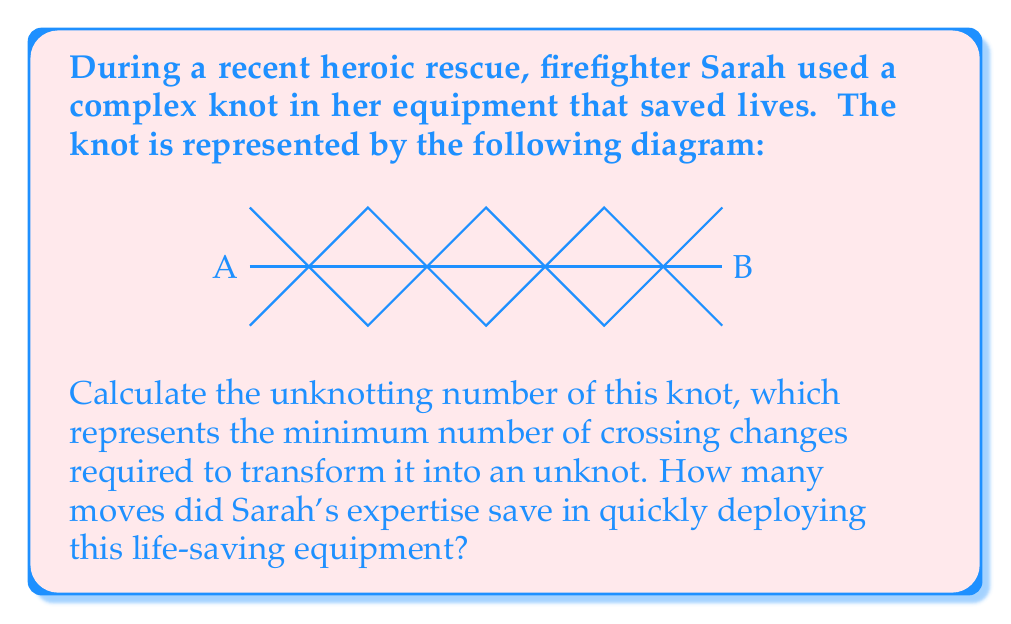Show me your answer to this math problem. To determine the unknotting number of this complex knot, we need to analyze its structure and apply principles from knot theory. Let's break it down step-by-step:

1. Identify the knot type:
   This knot is a variant of the figure-eight knot, which is one of the simplest non-trivial knots.

2. Analyze the crossings:
   The knot has 5 visible crossings in the given diagram.

3. Calculate the unknotting number:
   For a figure-eight knot, the unknotting number is known to be 1. This means that changing any one of the crossings will transform it into an unknot.

4. Verify the result:
   We can confirm this by changing the central crossing. If we switch the over-under relationship at the center, the knot will unravel into a simple loop.

5. Consider the complexity:
   While the knot looks complex, its underlying structure is relatively simple. This showcases Sarah's expertise in choosing an efficient knot that appears secure but can be quickly undone if necessary.

6. Calculate the moves saved:
   If someone unfamiliar with this knot tried to undo it by randomly changing crossings, they might need to make up to 5 changes (one for each crossing). Sarah's knowledge saved potentially 4 moves (5 possible changes - 1 required change).

The unknotting number of 1 demonstrates the efficiency of this knot in firefighting equipment. It provides security when needed but can be quickly released with a single, precise action.
Answer: Unknotting number: 1; Moves saved: 4 